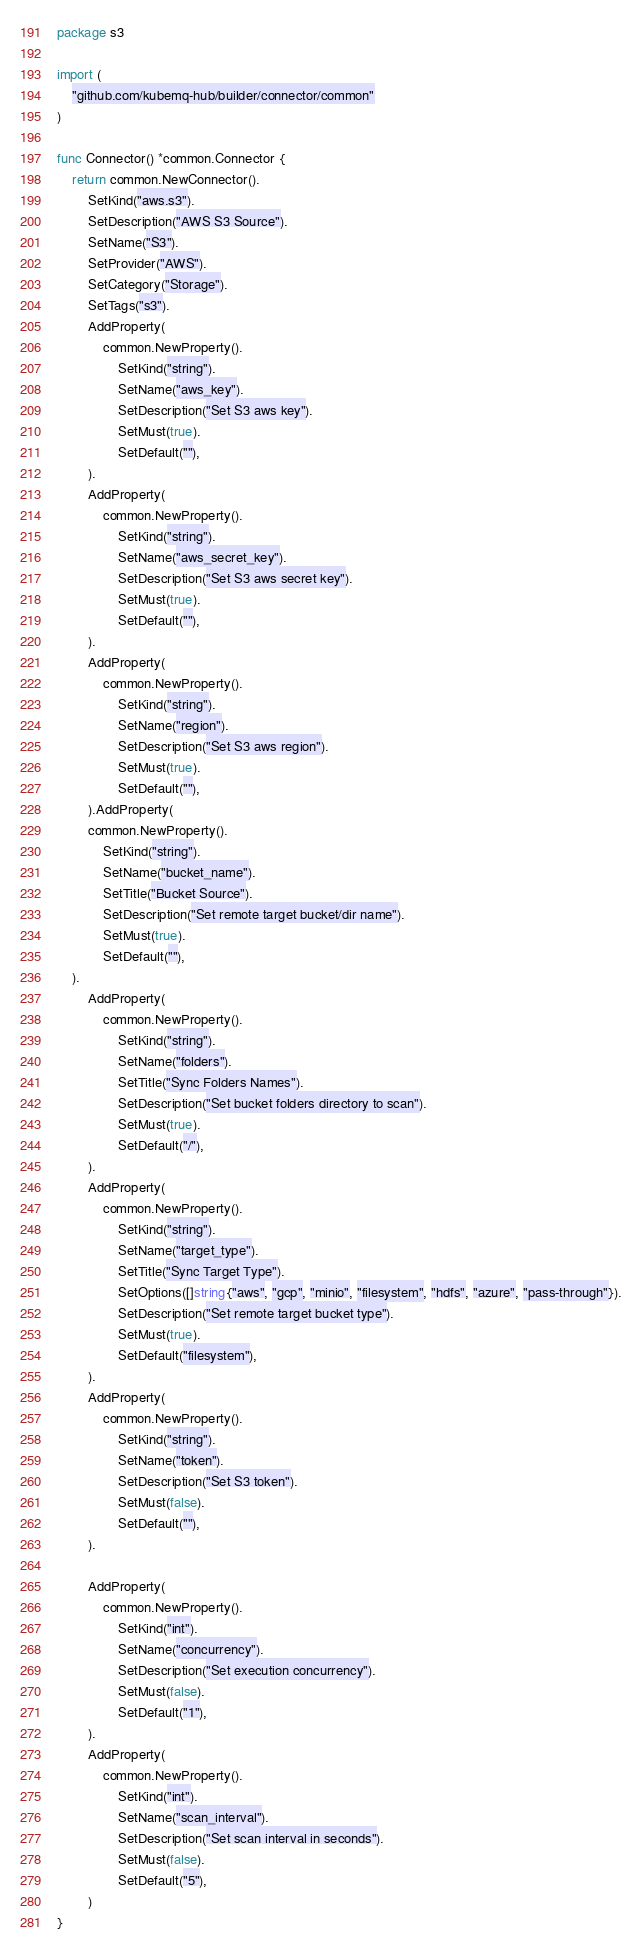Convert code to text. <code><loc_0><loc_0><loc_500><loc_500><_Go_>package s3

import (
	"github.com/kubemq-hub/builder/connector/common"
)

func Connector() *common.Connector {
	return common.NewConnector().
		SetKind("aws.s3").
		SetDescription("AWS S3 Source").
		SetName("S3").
		SetProvider("AWS").
		SetCategory("Storage").
		SetTags("s3").
		AddProperty(
			common.NewProperty().
				SetKind("string").
				SetName("aws_key").
				SetDescription("Set S3 aws key").
				SetMust(true).
				SetDefault(""),
		).
		AddProperty(
			common.NewProperty().
				SetKind("string").
				SetName("aws_secret_key").
				SetDescription("Set S3 aws secret key").
				SetMust(true).
				SetDefault(""),
		).
		AddProperty(
			common.NewProperty().
				SetKind("string").
				SetName("region").
				SetDescription("Set S3 aws region").
				SetMust(true).
				SetDefault(""),
		).AddProperty(
		common.NewProperty().
			SetKind("string").
			SetName("bucket_name").
			SetTitle("Bucket Source").
			SetDescription("Set remote target bucket/dir name").
			SetMust(true).
			SetDefault(""),
	).
		AddProperty(
			common.NewProperty().
				SetKind("string").
				SetName("folders").
				SetTitle("Sync Folders Names").
				SetDescription("Set bucket folders directory to scan").
				SetMust(true).
				SetDefault("/"),
		).
		AddProperty(
			common.NewProperty().
				SetKind("string").
				SetName("target_type").
				SetTitle("Sync Target Type").
				SetOptions([]string{"aws", "gcp", "minio", "filesystem", "hdfs", "azure", "pass-through"}).
				SetDescription("Set remote target bucket type").
				SetMust(true).
				SetDefault("filesystem"),
		).
		AddProperty(
			common.NewProperty().
				SetKind("string").
				SetName("token").
				SetDescription("Set S3 token").
				SetMust(false).
				SetDefault(""),
		).

		AddProperty(
			common.NewProperty().
				SetKind("int").
				SetName("concurrency").
				SetDescription("Set execution concurrency").
				SetMust(false).
				SetDefault("1"),
		).
		AddProperty(
			common.NewProperty().
				SetKind("int").
				SetName("scan_interval").
				SetDescription("Set scan interval in seconds").
				SetMust(false).
				SetDefault("5"),
		)
}
</code> 